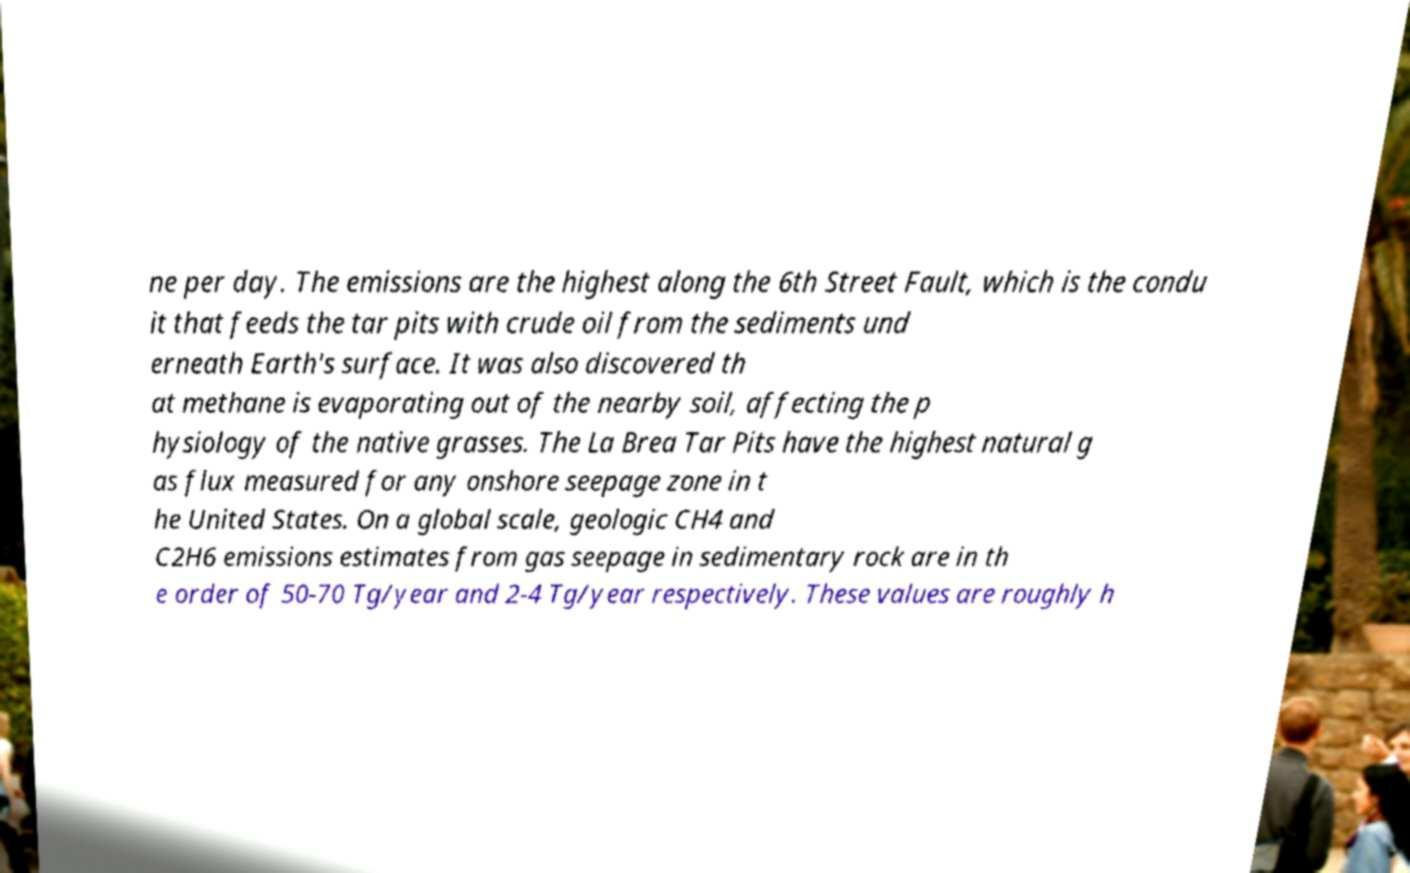What messages or text are displayed in this image? I need them in a readable, typed format. ne per day. The emissions are the highest along the 6th Street Fault, which is the condu it that feeds the tar pits with crude oil from the sediments und erneath Earth's surface. It was also discovered th at methane is evaporating out of the nearby soil, affecting the p hysiology of the native grasses. The La Brea Tar Pits have the highest natural g as flux measured for any onshore seepage zone in t he United States. On a global scale, geologic CH4 and C2H6 emissions estimates from gas seepage in sedimentary rock are in th e order of 50-70 Tg/year and 2-4 Tg/year respectively. These values are roughly h 